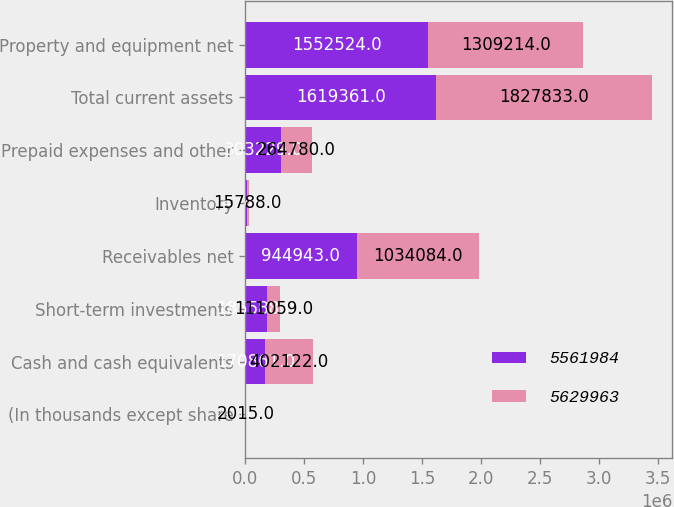<chart> <loc_0><loc_0><loc_500><loc_500><stacked_bar_chart><ecel><fcel>(In thousands except share<fcel>Cash and cash equivalents<fcel>Short-term investments<fcel>Receivables net<fcel>Inventory<fcel>Prepaid expenses and other<fcel>Total current assets<fcel>Property and equipment net<nl><fcel>5.56198e+06<fcel>2016<fcel>170861<fcel>185588<fcel>944943<fcel>14740<fcel>303229<fcel>1.61936e+06<fcel>1.55252e+06<nl><fcel>5.62996e+06<fcel>2015<fcel>402122<fcel>111059<fcel>1.03408e+06<fcel>15788<fcel>264780<fcel>1.82783e+06<fcel>1.30921e+06<nl></chart> 